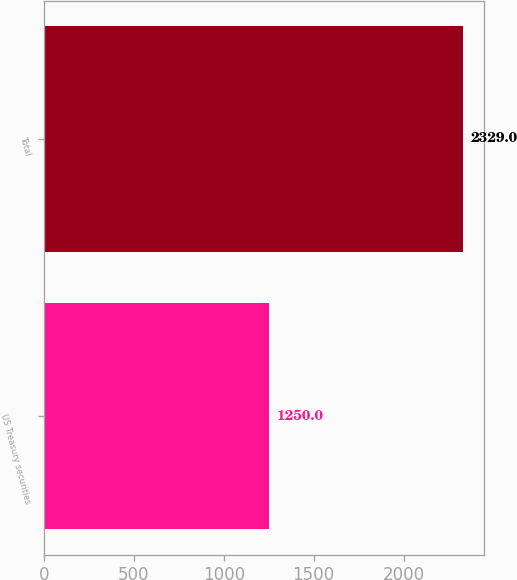<chart> <loc_0><loc_0><loc_500><loc_500><bar_chart><fcel>US Treasury securities<fcel>Total<nl><fcel>1250<fcel>2329<nl></chart> 